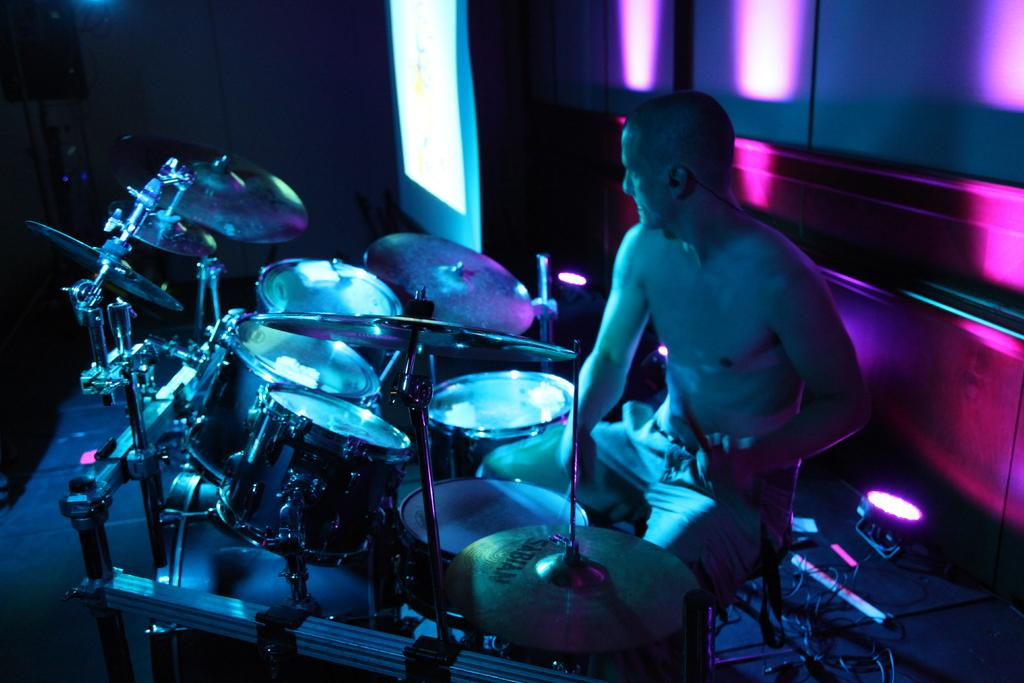What is the person in the image doing? The person is playing a music instrument in the image. What can be seen in the image besides the person playing the instrument? There are lights, wires, a surface, a wall, a screen, a light focus, and a few objects visible in the image. What type of potato is being used as a plate for the music instrument in the image? There is no potato or plate present in the image; the person is playing a music instrument on a surface. 